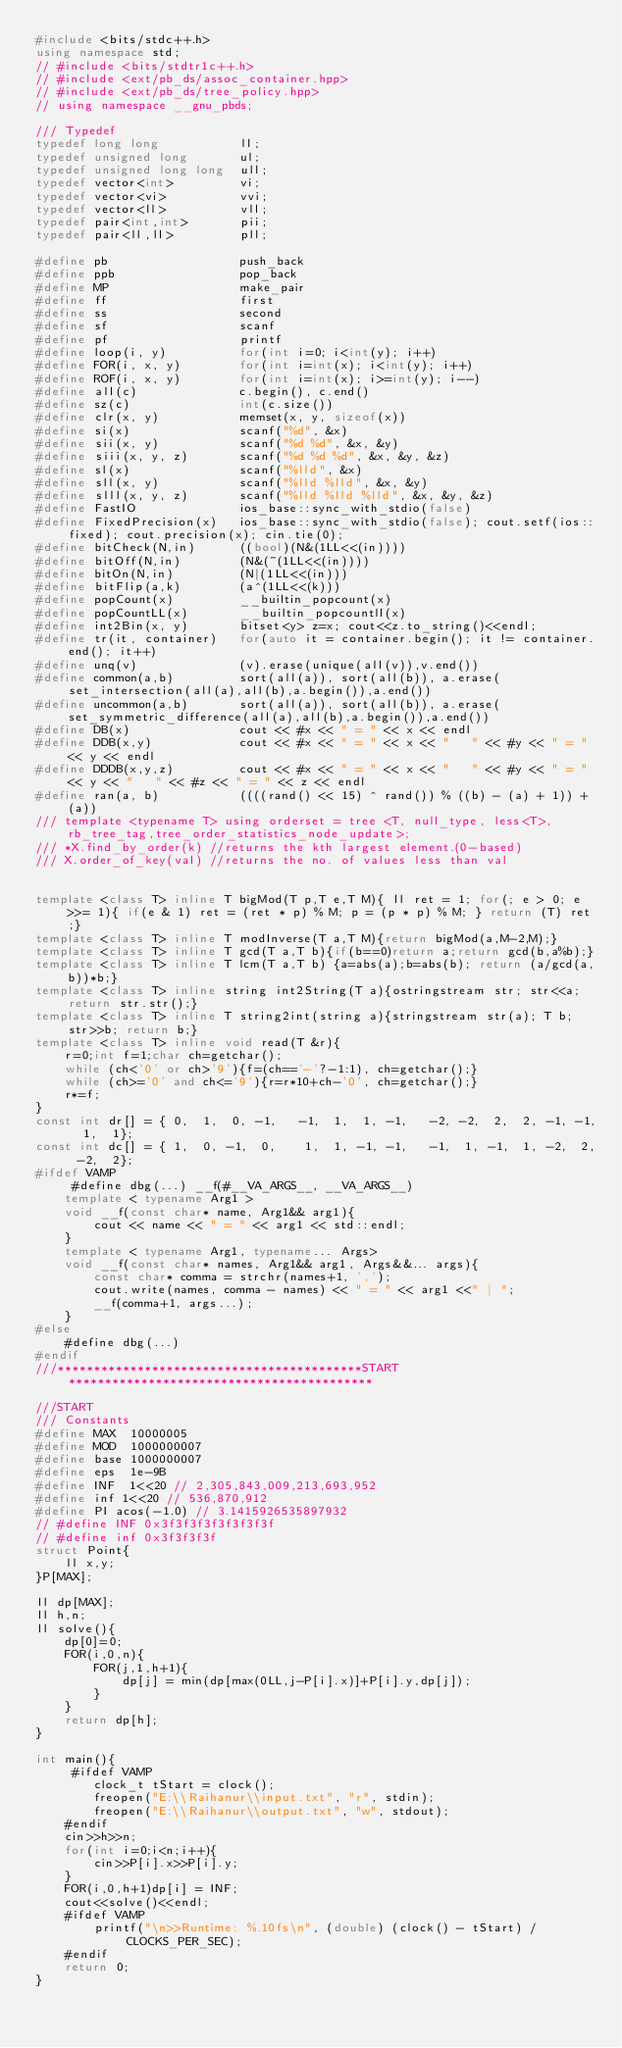Convert code to text. <code><loc_0><loc_0><loc_500><loc_500><_C++_>#include <bits/stdc++.h>
using namespace std;
// #include <bits/stdtr1c++.h>
// #include <ext/pb_ds/assoc_container.hpp>
// #include <ext/pb_ds/tree_policy.hpp>
// using namespace __gnu_pbds;
 
/// Typedef
typedef long long           ll;
typedef unsigned long       ul;
typedef unsigned long long  ull;
typedef vector<int>         vi;
typedef vector<vi>          vvi;
typedef vector<ll>          vll;
typedef pair<int,int>       pii;
typedef pair<ll,ll>         pll;
 
#define pb                  push_back
#define ppb                 pop_back
#define MP                  make_pair
#define ff                  first
#define ss                  second
#define sf                  scanf
#define pf                  printf
#define loop(i, y)          for(int i=0; i<int(y); i++)
#define FOR(i, x, y)        for(int i=int(x); i<int(y); i++)
#define ROF(i, x, y)        for(int i=int(x); i>=int(y); i--)
#define all(c)              c.begin(), c.end()
#define sz(c)               int(c.size())
#define clr(x, y)           memset(x, y, sizeof(x))
#define si(x)               scanf("%d", &x)
#define sii(x, y)           scanf("%d %d", &x, &y)
#define siii(x, y, z)       scanf("%d %d %d", &x, &y, &z)
#define sl(x)               scanf("%lld", &x)
#define sll(x, y)           scanf("%lld %lld", &x, &y)
#define slll(x, y, z)       scanf("%lld %lld %lld", &x, &y, &z)
#define FastIO              ios_base::sync_with_stdio(false)
#define FixedPrecision(x)   ios_base::sync_with_stdio(false); cout.setf(ios::fixed); cout.precision(x); cin.tie(0);
#define bitCheck(N,in)      ((bool)(N&(1LL<<(in))))
#define bitOff(N,in)        (N&(~(1LL<<(in))))
#define bitOn(N,in)         (N|(1LL<<(in)))
#define bitFlip(a,k)        (a^(1LL<<(k)))
#define popCount(x)         __builtin_popcount(x)
#define popCountLL(x)       __builtin_popcountll(x)
#define int2Bin(x, y)       bitset<y> z=x; cout<<z.to_string()<<endl;
#define tr(it, container)   for(auto it = container.begin(); it != container.end(); it++)
#define unq(v)              (v).erase(unique(all(v)),v.end())
#define common(a,b)         sort(all(a)), sort(all(b)), a.erase(set_intersection(all(a),all(b),a.begin()),a.end())
#define uncommon(a,b)       sort(all(a)), sort(all(b)), a.erase(set_symmetric_difference(all(a),all(b),a.begin()),a.end())
#define DB(x)               cout << #x << " = " << x << endl
#define DDB(x,y)            cout << #x << " = " << x << "   " << #y << " = " << y << endl
#define DDDB(x,y,z)         cout << #x << " = " << x << "   " << #y << " = " << y << "   " << #z << " = " << z << endl
#define ran(a, b)           ((((rand() << 15) ^ rand()) % ((b) - (a) + 1)) + (a))
/// template <typename T> using orderset = tree <T, null_type, less<T>, rb_tree_tag,tree_order_statistics_node_update>;
/// *X.find_by_order(k) //returns the kth largest element.(0-based)
/// X.order_of_key(val) //returns the no. of values less than val
 
 
template <class T> inline T bigMod(T p,T e,T M){ ll ret = 1; for(; e > 0; e >>= 1){ if(e & 1) ret = (ret * p) % M; p = (p * p) % M; } return (T) ret;}
template <class T> inline T modInverse(T a,T M){return bigMod(a,M-2,M);}
template <class T> inline T gcd(T a,T b){if(b==0)return a;return gcd(b,a%b);}
template <class T> inline T lcm(T a,T b) {a=abs(a);b=abs(b); return (a/gcd(a,b))*b;}
template <class T> inline string int2String(T a){ostringstream str; str<<a; return str.str();}
template <class T> inline T string2int(string a){stringstream str(a); T b; str>>b; return b;}
template <class T> inline void read(T &r){
    r=0;int f=1;char ch=getchar();
    while (ch<'0' or ch>'9'){f=(ch=='-'?-1:1), ch=getchar();}
    while (ch>='0' and ch<='9'){r=r*10+ch-'0', ch=getchar();}
    r*=f;
}
const int dr[] = { 0,  1,  0, -1,   -1,  1,  1, -1,   -2, -2,  2,  2, -1, -1,  1,  1};
const int dc[] = { 1,  0, -1,  0,    1,  1, -1, -1,   -1,  1, -1,  1, -2,  2, -2,  2};
#ifdef VAMP
     #define dbg(...) __f(#__VA_ARGS__, __VA_ARGS__)
    template < typename Arg1 >
    void __f(const char* name, Arg1&& arg1){
        cout << name << " = " << arg1 << std::endl;
    }
    template < typename Arg1, typename... Args>
    void __f(const char* names, Arg1&& arg1, Args&&... args){
        const char* comma = strchr(names+1, ',');
        cout.write(names, comma - names) << " = " << arg1 <<" | ";
        __f(comma+1, args...);
    }
#else
    #define dbg(...)
#endif
///******************************************START******************************************
 
///START
/// Constants
#define MAX  10000005
#define MOD  1000000007
#define base 1000000007
#define eps  1e-9B
#define INF  1<<20 // 2,305,843,009,213,693,952
#define inf 1<<20 // 536,870,912
#define PI acos(-1.0) // 3.1415926535897932
// #define INF 0x3f3f3f3f3f3f3f3f
// #define inf 0x3f3f3f3f
struct Point{
    ll x,y;
}P[MAX];

ll dp[MAX];
ll h,n;
ll solve(){
    dp[0]=0;
    FOR(i,0,n){
        FOR(j,1,h+1){
            dp[j] = min(dp[max(0LL,j-P[i].x)]+P[i].y,dp[j]);
        }
    }
    return dp[h];
}

int main(){
     #ifdef VAMP
        clock_t tStart = clock();
        freopen("E:\\Raihanur\\input.txt", "r", stdin);
        freopen("E:\\Raihanur\\output.txt", "w", stdout);
    #endif
    cin>>h>>n;
    for(int i=0;i<n;i++){
        cin>>P[i].x>>P[i].y;
    }
    FOR(i,0,h+1)dp[i] = INF;
    cout<<solve()<<endl;
    #ifdef VAMP
        printf("\n>>Runtime: %.10fs\n", (double) (clock() - tStart) / CLOCKS_PER_SEC);
    #endif
    return 0;
}</code> 